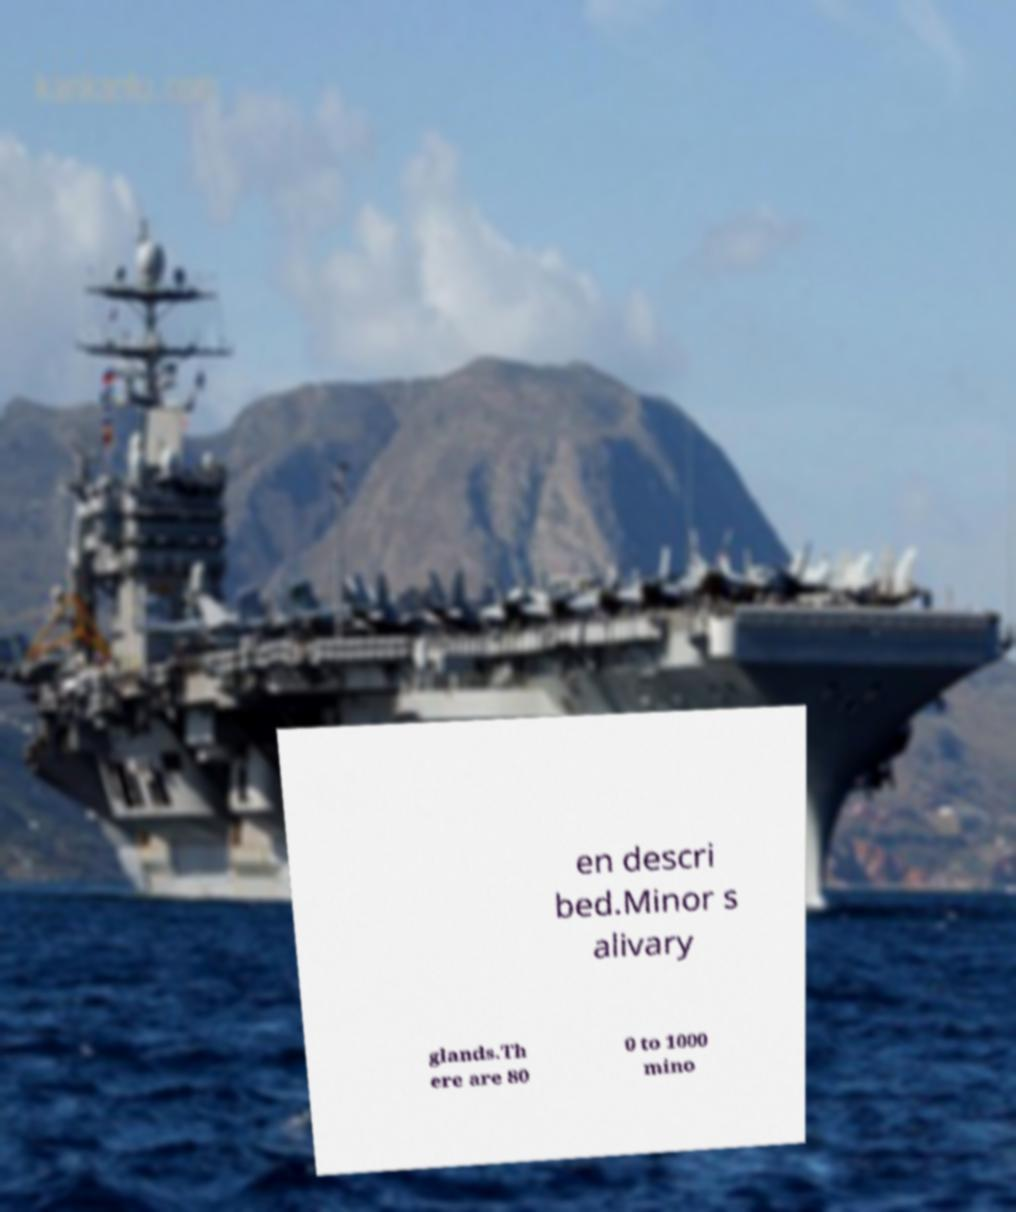Could you assist in decoding the text presented in this image and type it out clearly? en descri bed.Minor s alivary glands.Th ere are 80 0 to 1000 mino 